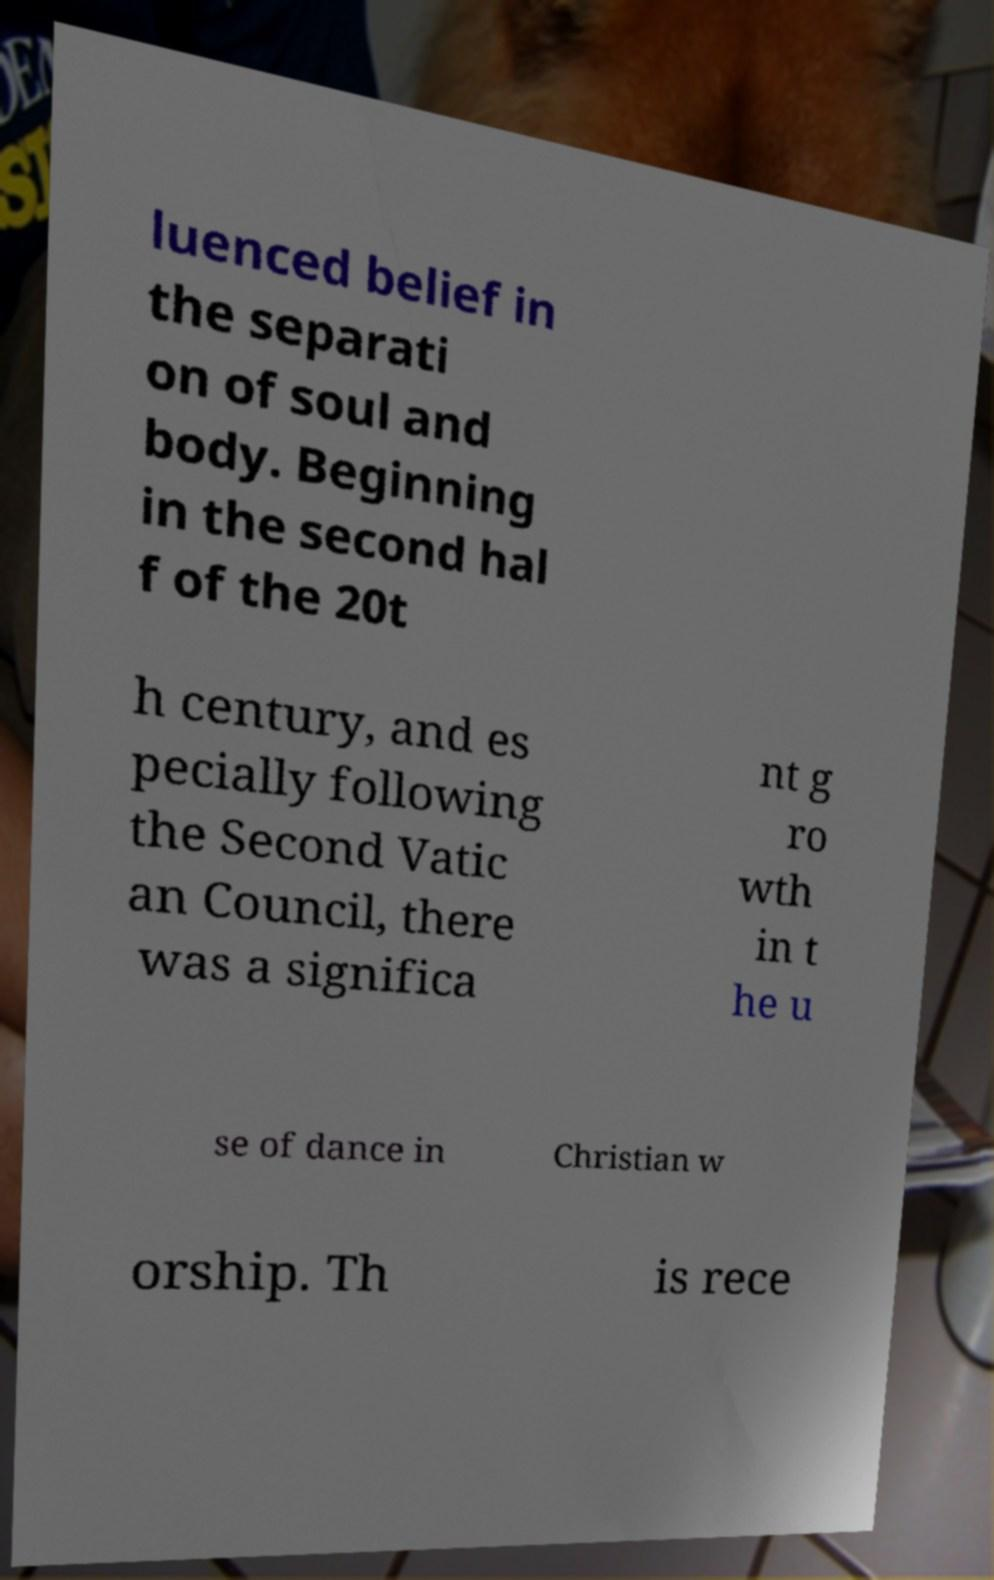Could you assist in decoding the text presented in this image and type it out clearly? luenced belief in the separati on of soul and body. Beginning in the second hal f of the 20t h century, and es pecially following the Second Vatic an Council, there was a significa nt g ro wth in t he u se of dance in Christian w orship. Th is rece 